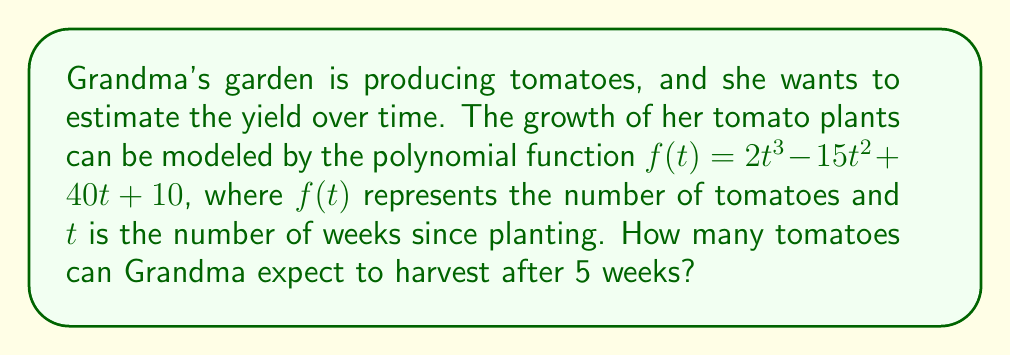Teach me how to tackle this problem. To find the number of tomatoes after 5 weeks, we need to evaluate the function $f(t)$ at $t = 5$. Let's break this down step-by-step:

1) The polynomial function is $f(t) = 2t^3 - 15t^2 + 40t + 10$

2) We need to calculate $f(5)$, so we substitute $t = 5$ into the function:

   $f(5) = 2(5)^3 - 15(5)^2 + 40(5) + 10$

3) Let's evaluate each term:
   
   $2(5)^3 = 2 \cdot 125 = 250$
   $-15(5)^2 = -15 \cdot 25 = -375$
   $40(5) = 200$
   $10$ remains as is

4) Now, we add all these terms:

   $f(5) = 250 - 375 + 200 + 10$

5) Simplifying:

   $f(5) = 85$

Therefore, after 5 weeks, Grandma can expect to harvest 85 tomatoes from her garden.
Answer: 85 tomatoes 